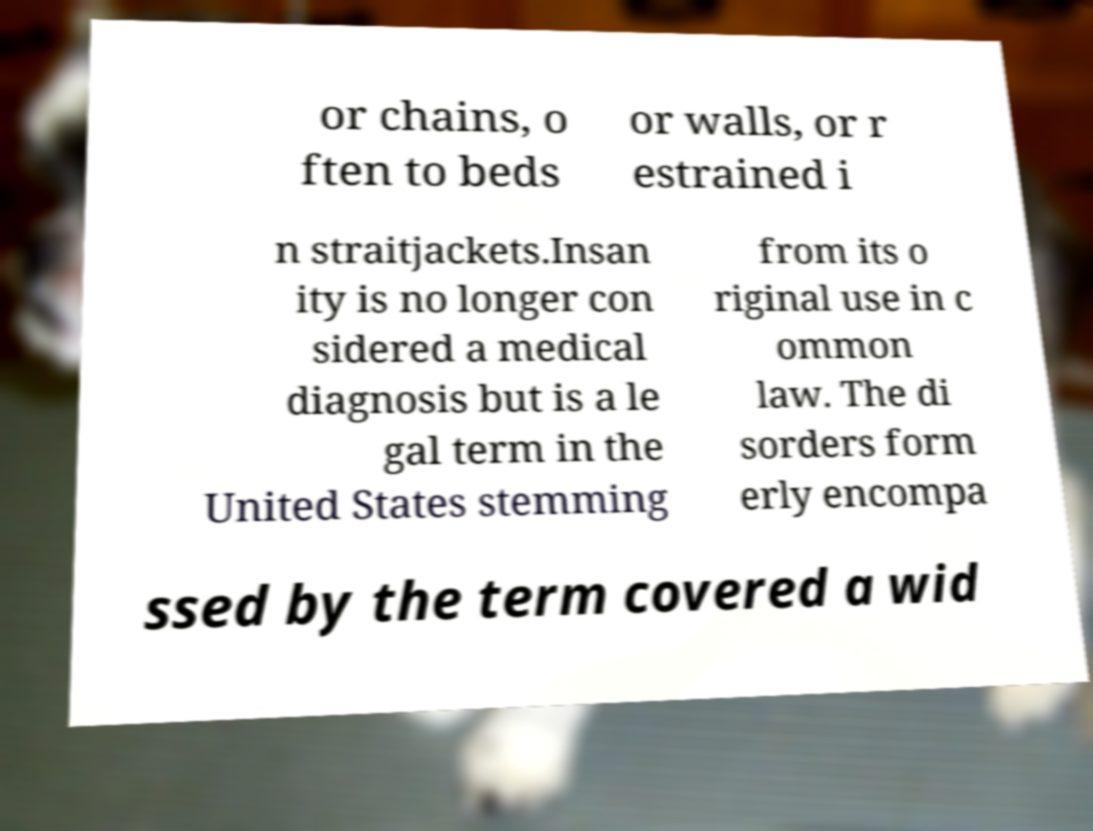Can you read and provide the text displayed in the image?This photo seems to have some interesting text. Can you extract and type it out for me? or chains, o ften to beds or walls, or r estrained i n straitjackets.Insan ity is no longer con sidered a medical diagnosis but is a le gal term in the United States stemming from its o riginal use in c ommon law. The di sorders form erly encompa ssed by the term covered a wid 